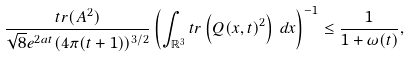Convert formula to latex. <formula><loc_0><loc_0><loc_500><loc_500>\frac { t r ( A ^ { 2 } ) } { \sqrt { 8 } e ^ { 2 a t } ( 4 \pi ( t + 1 ) ) ^ { 3 / 2 } } \left ( \int _ { \mathbb { R } ^ { 3 } } t r \left ( Q ( x , t ) ^ { 2 } \right ) \, d x \right ) ^ { - 1 } \leq \frac { 1 } { 1 + \omega ( t ) } ,</formula> 